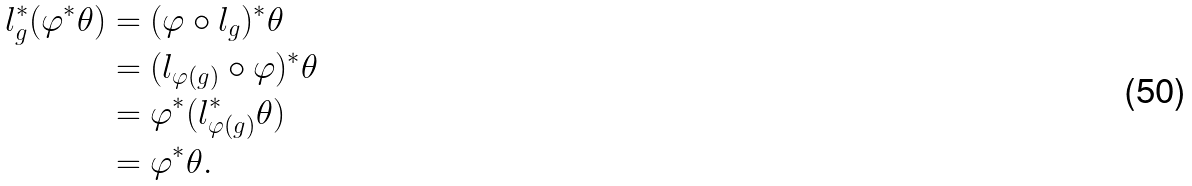<formula> <loc_0><loc_0><loc_500><loc_500>l _ { g } ^ { \ast } ( \varphi ^ { \ast } \theta ) & = ( \varphi \circ l _ { g } ) ^ { \ast } \theta \\ & = ( l _ { \varphi ( g ) } \circ \varphi ) ^ { \ast } \theta \\ & = \varphi ^ { \ast } ( l _ { \varphi ( g ) } ^ { \ast } \theta ) \\ & = \varphi ^ { \ast } \theta .</formula> 